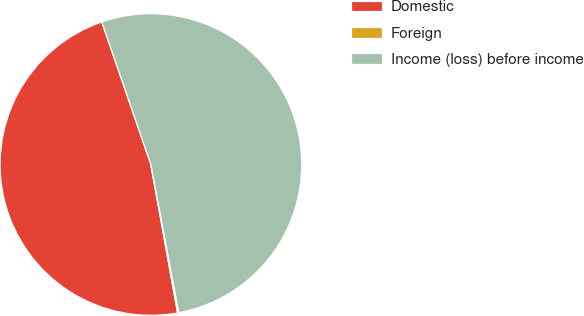Convert chart. <chart><loc_0><loc_0><loc_500><loc_500><pie_chart><fcel>Domestic<fcel>Foreign<fcel>Income (loss) before income<nl><fcel>47.55%<fcel>0.13%<fcel>52.31%<nl></chart> 